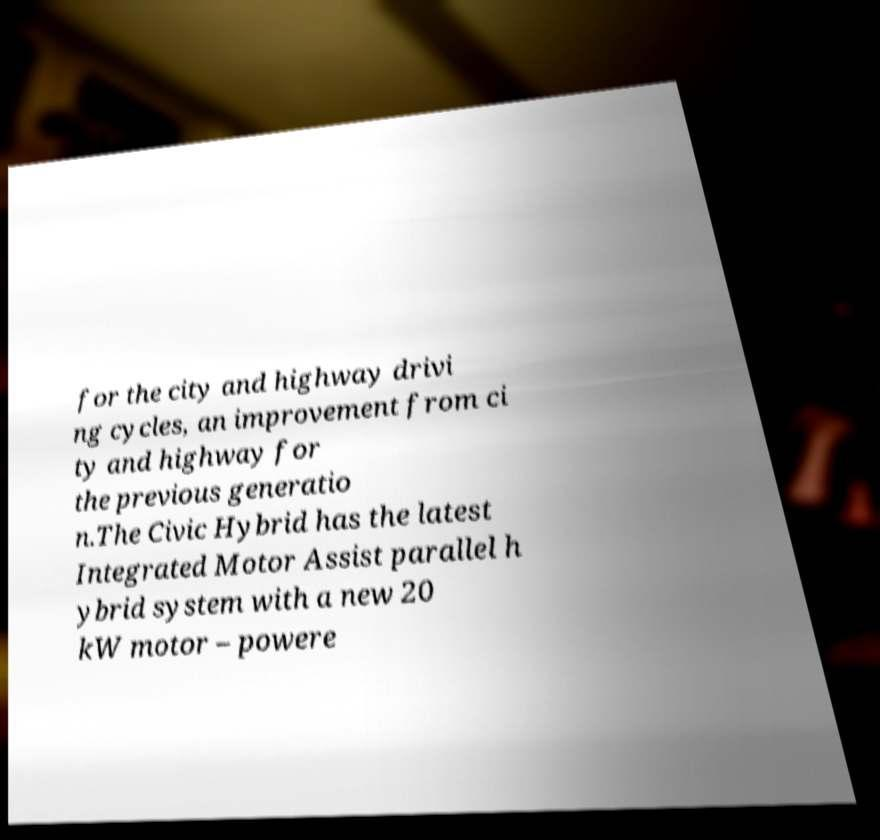Can you accurately transcribe the text from the provided image for me? for the city and highway drivi ng cycles, an improvement from ci ty and highway for the previous generatio n.The Civic Hybrid has the latest Integrated Motor Assist parallel h ybrid system with a new 20 kW motor – powere 